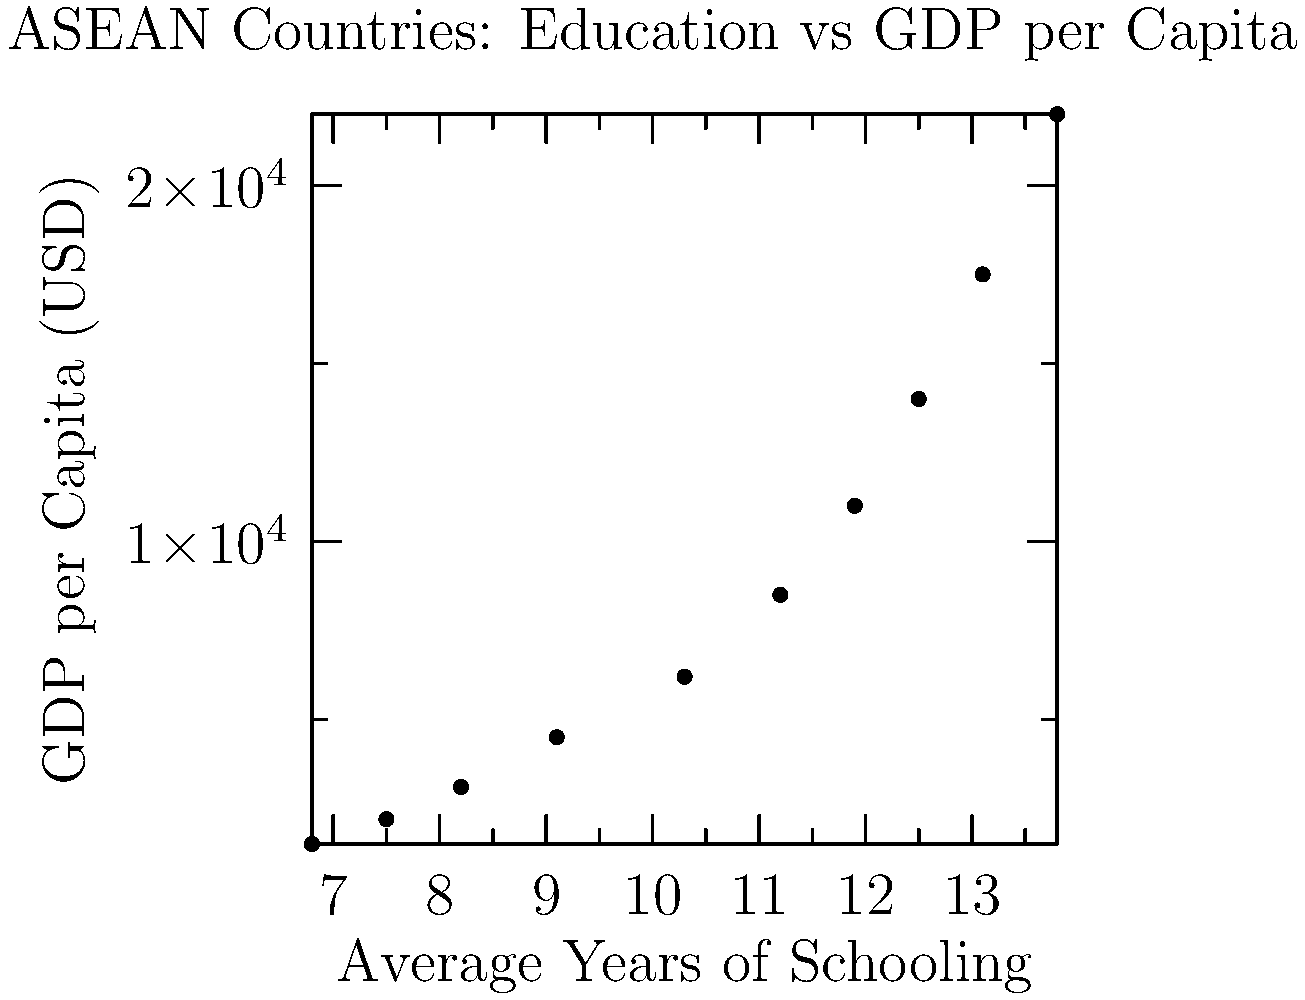Based on the scatter plot showing the relationship between average years of schooling and GDP per capita in ASEAN countries, what can be inferred about the correlation between education levels and economic indicators? Calculate the Pearson correlation coefficient (r) to support your answer. To answer this question and calculate the Pearson correlation coefficient (r), we'll follow these steps:

1. Observe the scatter plot:
   The plot shows a clear positive trend, suggesting a positive correlation between average years of schooling and GDP per capita.

2. Calculate the Pearson correlation coefficient:
   The formula for r is:
   $$ r = \frac{\sum_{i=1}^{n} (x_i - \bar{x})(y_i - \bar{y})}{\sqrt{\sum_{i=1}^{n} (x_i - \bar{x})^2 \sum_{i=1}^{n} (y_i - \bar{y})^2}} $$

   Where:
   $x_i$ = education data points
   $y_i$ = GDP per capita data points
   $\bar{x}$ = mean of education data
   $\bar{y}$ = mean of GDP per capita data
   $n$ = number of data points (10 in this case)

3. Calculate means:
   $\bar{x} = 10.44$ years
   $\bar{y} = 9050$ USD

4. Calculate sums for numerator and denominator:
   $\sum (x_i - \bar{x})(y_i - \bar{y}) = 162,304.6$
   $\sum (x_i - \bar{x})^2 = 46.428$
   $\sum (y_i - \bar{y})^2 = 368,645,000$

5. Plug into the formula:
   $$ r = \frac{162,304.6}{\sqrt{46.428 \times 368,645,000}} = 0.9877 $$

6. Interpret the result:
   The Pearson correlation coefficient of 0.9877 indicates a very strong positive correlation between education levels and GDP per capita in ASEAN countries.
Answer: Strong positive correlation (r = 0.9877) between education levels and GDP per capita in ASEAN countries. 